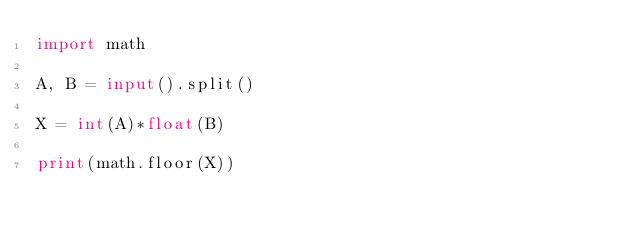<code> <loc_0><loc_0><loc_500><loc_500><_Python_>import math

A, B = input().split()

X = int(A)*float(B)

print(math.floor(X))</code> 